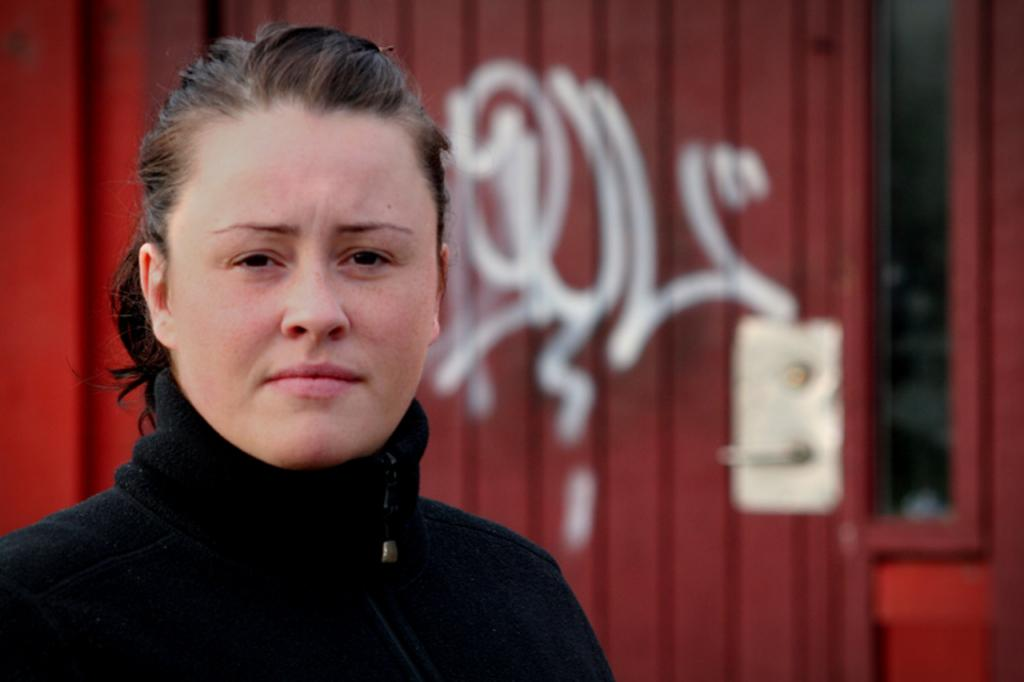What is present in the image? There is a person in the image. Can you describe what the person is wearing? The person is wearing a black dress. What can be seen in the background of the image? There is a door visible in the background of the image. How many birds can be seen flying in the image? There are no birds visible in the image. What type of connection is the person making in the image? The image does not provide information about any connections being made by the person. 